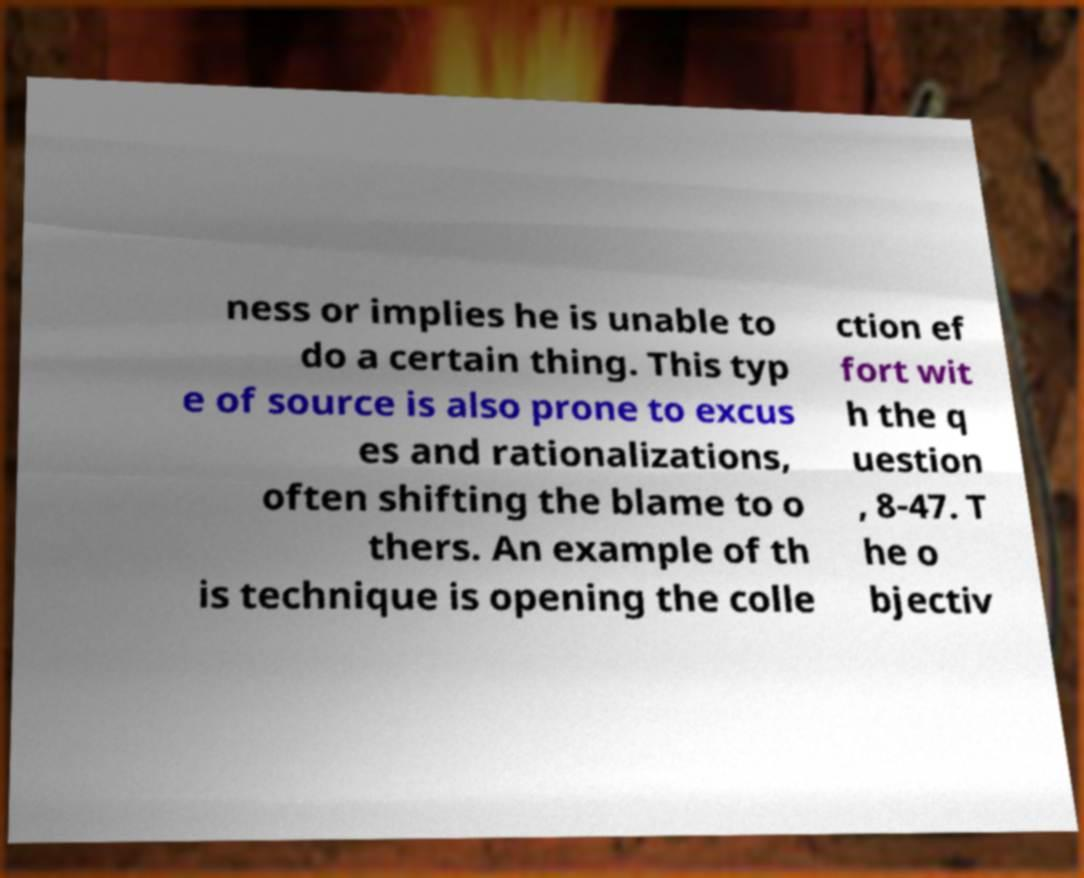Can you accurately transcribe the text from the provided image for me? ness or implies he is unable to do a certain thing. This typ e of source is also prone to excus es and rationalizations, often shifting the blame to o thers. An example of th is technique is opening the colle ction ef fort wit h the q uestion , 8-47. T he o bjectiv 